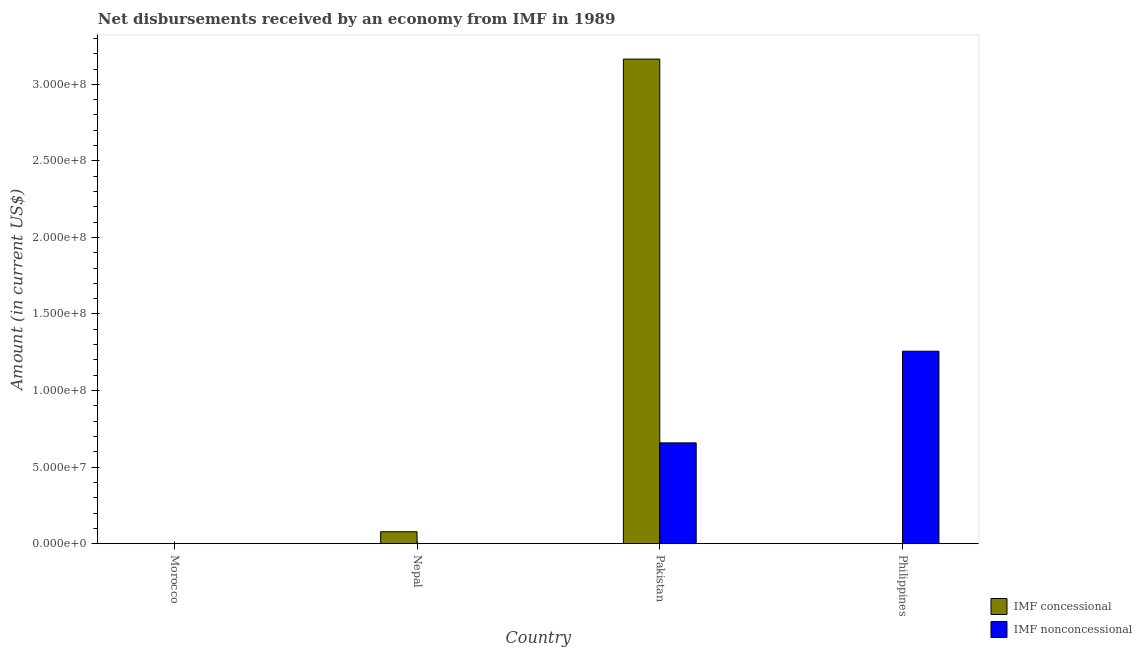How many different coloured bars are there?
Your answer should be compact. 2. Are the number of bars per tick equal to the number of legend labels?
Your response must be concise. No. How many bars are there on the 2nd tick from the right?
Keep it short and to the point. 2. What is the label of the 1st group of bars from the left?
Give a very brief answer. Morocco. In how many cases, is the number of bars for a given country not equal to the number of legend labels?
Keep it short and to the point. 3. What is the net non concessional disbursements from imf in Pakistan?
Your answer should be very brief. 6.58e+07. Across all countries, what is the maximum net non concessional disbursements from imf?
Your answer should be compact. 1.26e+08. Across all countries, what is the minimum net non concessional disbursements from imf?
Make the answer very short. 0. What is the total net concessional disbursements from imf in the graph?
Offer a terse response. 3.24e+08. What is the difference between the net concessional disbursements from imf in Nepal and the net non concessional disbursements from imf in Pakistan?
Provide a short and direct response. -5.80e+07. What is the average net concessional disbursements from imf per country?
Ensure brevity in your answer.  8.11e+07. What is the difference between the net concessional disbursements from imf and net non concessional disbursements from imf in Pakistan?
Offer a terse response. 2.51e+08. What is the ratio of the net concessional disbursements from imf in Nepal to that in Pakistan?
Keep it short and to the point. 0.02. Is the net concessional disbursements from imf in Nepal less than that in Pakistan?
Your response must be concise. Yes. What is the difference between the highest and the lowest net concessional disbursements from imf?
Offer a very short reply. 3.16e+08. Is the sum of the net concessional disbursements from imf in Nepal and Pakistan greater than the maximum net non concessional disbursements from imf across all countries?
Keep it short and to the point. Yes. How many bars are there?
Offer a very short reply. 4. Are all the bars in the graph horizontal?
Your response must be concise. No. How many countries are there in the graph?
Ensure brevity in your answer.  4. What is the difference between two consecutive major ticks on the Y-axis?
Offer a very short reply. 5.00e+07. Are the values on the major ticks of Y-axis written in scientific E-notation?
Offer a terse response. Yes. Does the graph contain any zero values?
Ensure brevity in your answer.  Yes. Does the graph contain grids?
Provide a succinct answer. No. Where does the legend appear in the graph?
Your answer should be compact. Bottom right. How many legend labels are there?
Provide a short and direct response. 2. How are the legend labels stacked?
Make the answer very short. Vertical. What is the title of the graph?
Ensure brevity in your answer.  Net disbursements received by an economy from IMF in 1989. Does "RDB concessional" appear as one of the legend labels in the graph?
Offer a very short reply. No. What is the label or title of the X-axis?
Keep it short and to the point. Country. What is the label or title of the Y-axis?
Give a very brief answer. Amount (in current US$). What is the Amount (in current US$) in IMF concessional in Morocco?
Your answer should be very brief. 0. What is the Amount (in current US$) in IMF nonconcessional in Morocco?
Give a very brief answer. 0. What is the Amount (in current US$) of IMF concessional in Nepal?
Your answer should be very brief. 7.79e+06. What is the Amount (in current US$) in IMF nonconcessional in Nepal?
Provide a succinct answer. 0. What is the Amount (in current US$) in IMF concessional in Pakistan?
Give a very brief answer. 3.16e+08. What is the Amount (in current US$) in IMF nonconcessional in Pakistan?
Your answer should be very brief. 6.58e+07. What is the Amount (in current US$) in IMF nonconcessional in Philippines?
Ensure brevity in your answer.  1.26e+08. Across all countries, what is the maximum Amount (in current US$) of IMF concessional?
Your answer should be compact. 3.16e+08. Across all countries, what is the maximum Amount (in current US$) in IMF nonconcessional?
Ensure brevity in your answer.  1.26e+08. Across all countries, what is the minimum Amount (in current US$) of IMF concessional?
Your response must be concise. 0. Across all countries, what is the minimum Amount (in current US$) of IMF nonconcessional?
Your answer should be compact. 0. What is the total Amount (in current US$) in IMF concessional in the graph?
Make the answer very short. 3.24e+08. What is the total Amount (in current US$) in IMF nonconcessional in the graph?
Give a very brief answer. 1.92e+08. What is the difference between the Amount (in current US$) of IMF concessional in Nepal and that in Pakistan?
Offer a terse response. -3.09e+08. What is the difference between the Amount (in current US$) of IMF nonconcessional in Pakistan and that in Philippines?
Give a very brief answer. -5.99e+07. What is the difference between the Amount (in current US$) in IMF concessional in Nepal and the Amount (in current US$) in IMF nonconcessional in Pakistan?
Make the answer very short. -5.80e+07. What is the difference between the Amount (in current US$) in IMF concessional in Nepal and the Amount (in current US$) in IMF nonconcessional in Philippines?
Keep it short and to the point. -1.18e+08. What is the difference between the Amount (in current US$) of IMF concessional in Pakistan and the Amount (in current US$) of IMF nonconcessional in Philippines?
Offer a very short reply. 1.91e+08. What is the average Amount (in current US$) of IMF concessional per country?
Offer a terse response. 8.11e+07. What is the average Amount (in current US$) in IMF nonconcessional per country?
Provide a short and direct response. 4.79e+07. What is the difference between the Amount (in current US$) of IMF concessional and Amount (in current US$) of IMF nonconcessional in Pakistan?
Your answer should be compact. 2.51e+08. What is the ratio of the Amount (in current US$) of IMF concessional in Nepal to that in Pakistan?
Offer a terse response. 0.02. What is the ratio of the Amount (in current US$) in IMF nonconcessional in Pakistan to that in Philippines?
Keep it short and to the point. 0.52. What is the difference between the highest and the lowest Amount (in current US$) in IMF concessional?
Your answer should be very brief. 3.16e+08. What is the difference between the highest and the lowest Amount (in current US$) in IMF nonconcessional?
Give a very brief answer. 1.26e+08. 